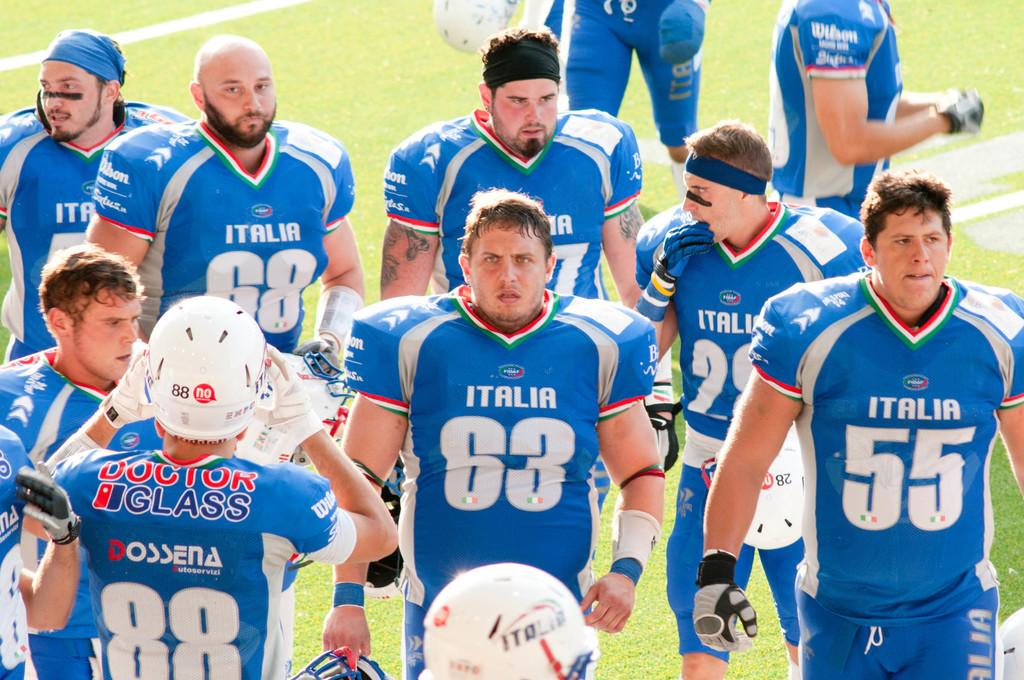What doctor is sponsoring this team?
Offer a terse response. Glass. What is the number of the player on the furthest right?
Your answer should be very brief. 55. 